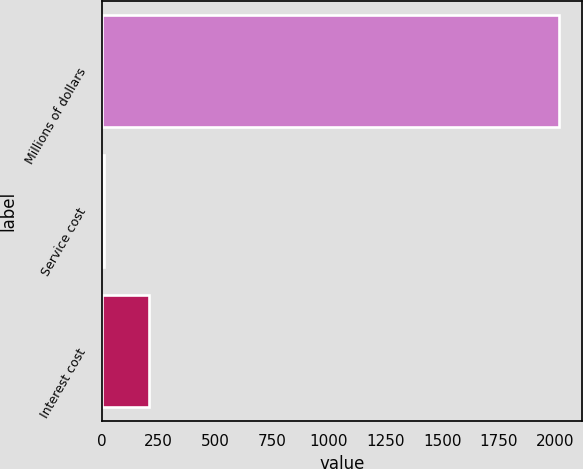Convert chart. <chart><loc_0><loc_0><loc_500><loc_500><bar_chart><fcel>Millions of dollars<fcel>Service cost<fcel>Interest cost<nl><fcel>2017<fcel>7<fcel>208<nl></chart> 